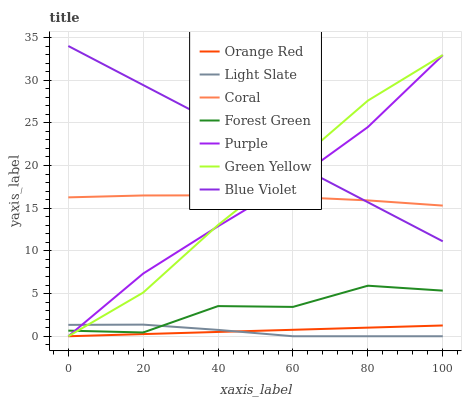Does Coral have the minimum area under the curve?
Answer yes or no. No. Does Coral have the maximum area under the curve?
Answer yes or no. No. Is Coral the smoothest?
Answer yes or no. No. Is Coral the roughest?
Answer yes or no. No. Does Coral have the lowest value?
Answer yes or no. No. Does Coral have the highest value?
Answer yes or no. No. Is Orange Red less than Blue Violet?
Answer yes or no. Yes. Is Blue Violet greater than Orange Red?
Answer yes or no. Yes. Does Orange Red intersect Blue Violet?
Answer yes or no. No. 